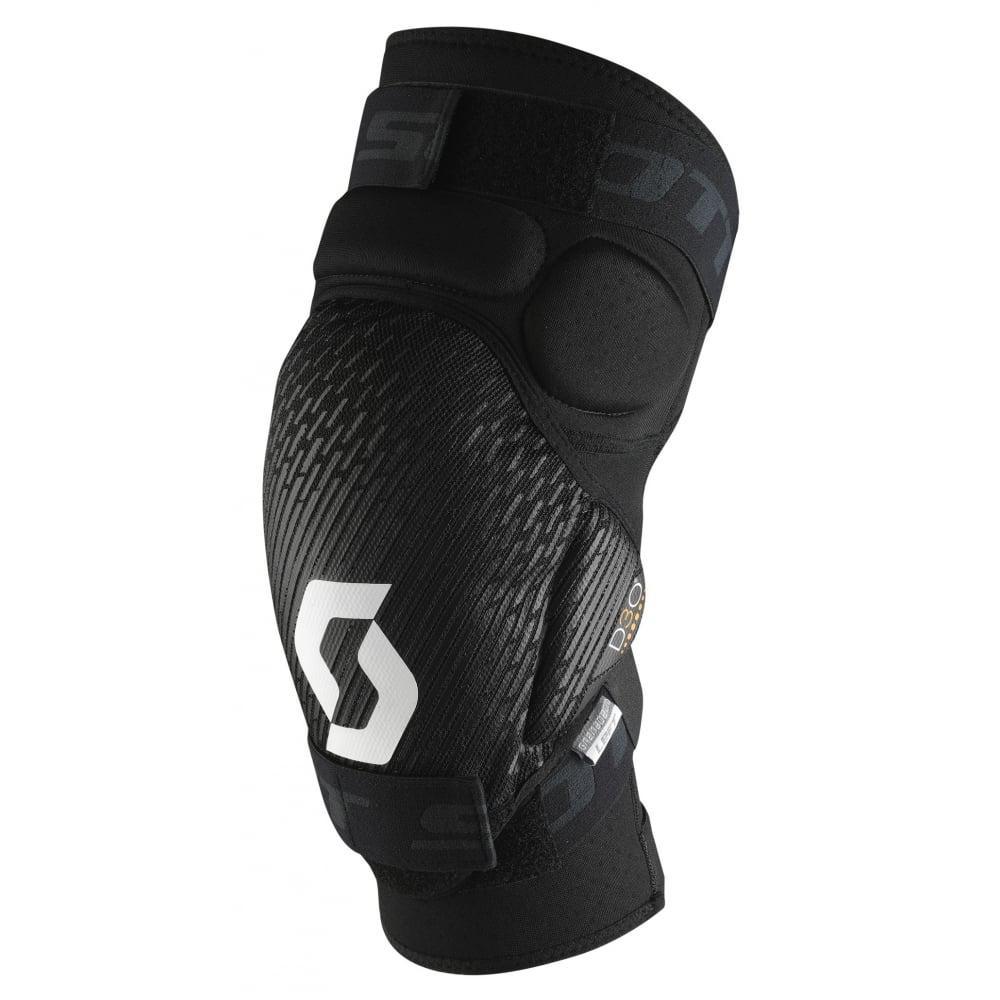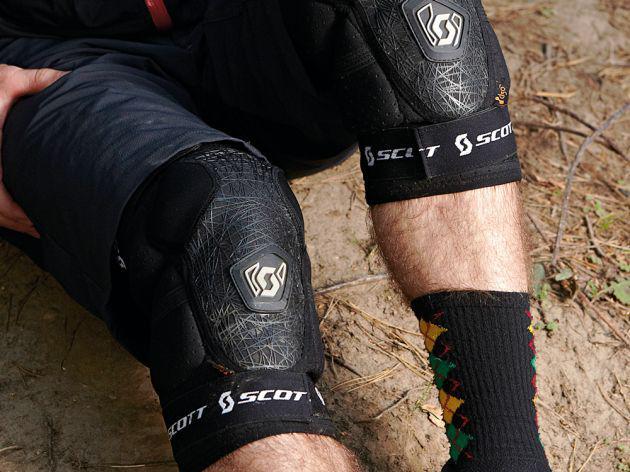The first image is the image on the left, the second image is the image on the right. Evaluate the accuracy of this statement regarding the images: "The knee guards are being worn by a person in one of the images.". Is it true? Answer yes or no. Yes. The first image is the image on the left, the second image is the image on the right. Considering the images on both sides, is "The left image features an unworn black knee pad, while the right image shows a pair of human legs wearing a pair of black knee pads." valid? Answer yes or no. Yes. 